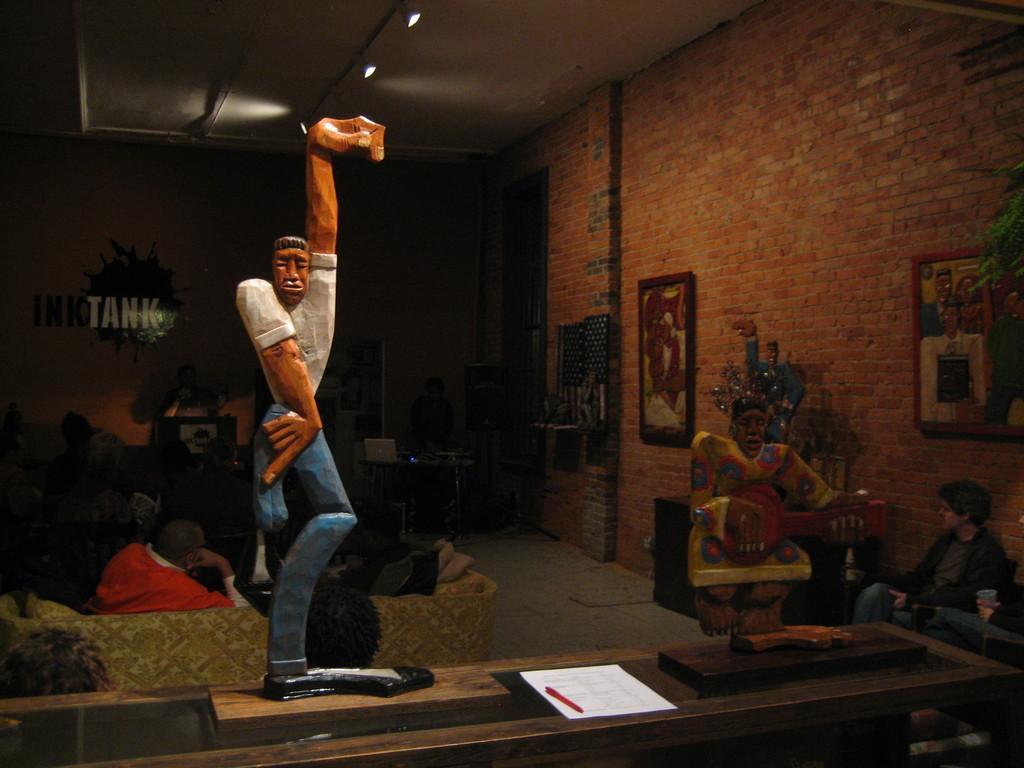In one or two sentences, can you explain what this image depicts? In this picture there are statues of a lady and a man on the right and left side of the image and there are people those who are sitting on the left side of the image, there are portraits on the wall, on the right side of the image and there is a boy who is sitting on the sofa on the right side of the image. 